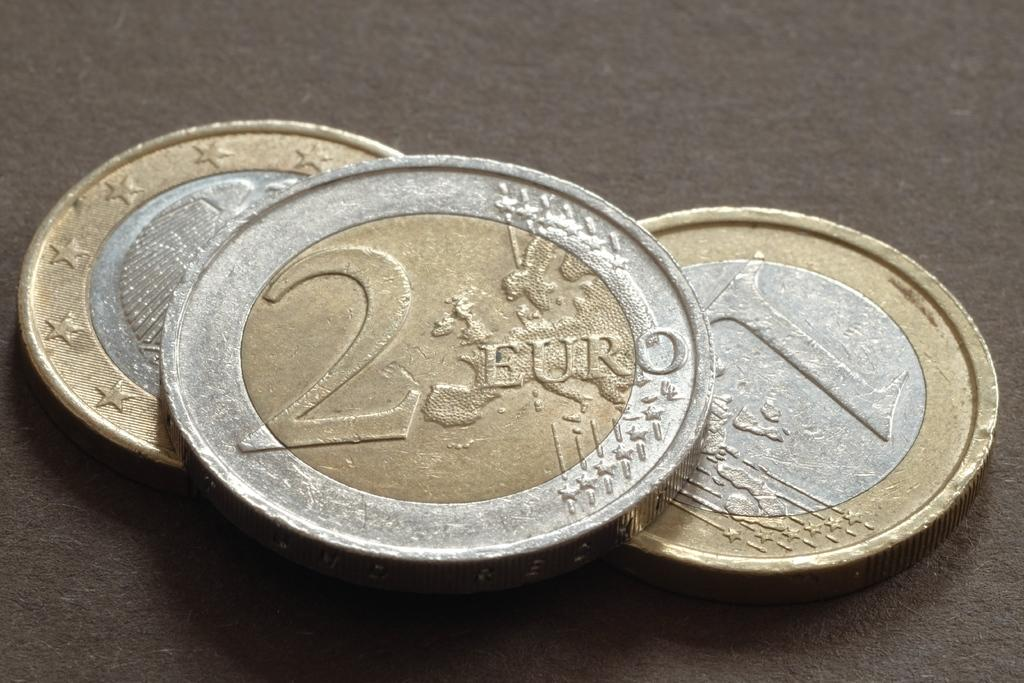<image>
Give a short and clear explanation of the subsequent image. Two gold-edged coins sit below a 2 Euro. 